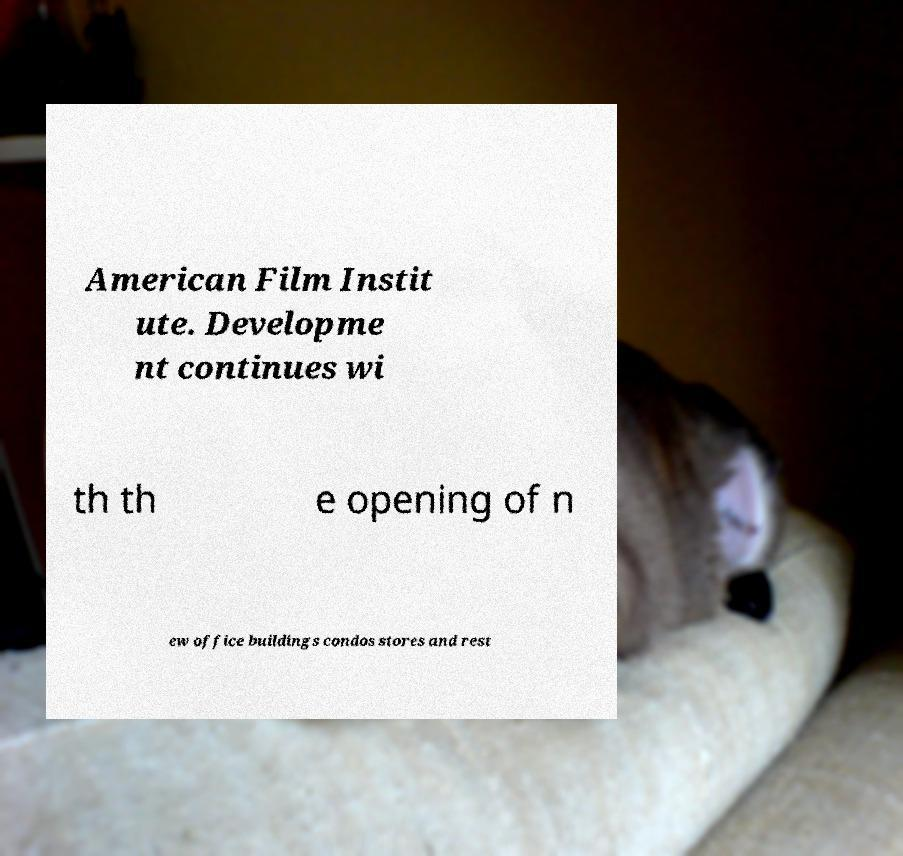Could you assist in decoding the text presented in this image and type it out clearly? American Film Instit ute. Developme nt continues wi th th e opening of n ew office buildings condos stores and rest 